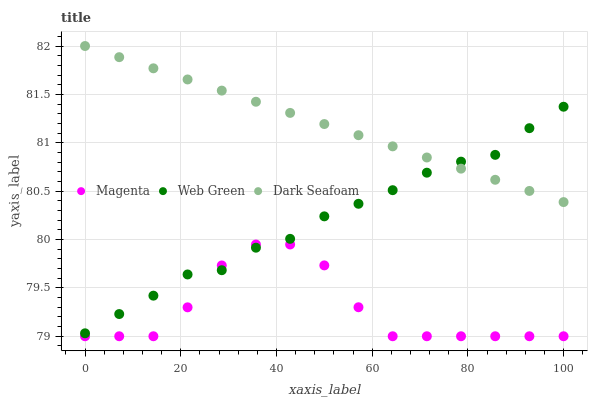Does Magenta have the minimum area under the curve?
Answer yes or no. Yes. Does Dark Seafoam have the maximum area under the curve?
Answer yes or no. Yes. Does Web Green have the minimum area under the curve?
Answer yes or no. No. Does Web Green have the maximum area under the curve?
Answer yes or no. No. Is Dark Seafoam the smoothest?
Answer yes or no. Yes. Is Magenta the roughest?
Answer yes or no. Yes. Is Web Green the smoothest?
Answer yes or no. No. Is Web Green the roughest?
Answer yes or no. No. Does Magenta have the lowest value?
Answer yes or no. Yes. Does Web Green have the lowest value?
Answer yes or no. No. Does Dark Seafoam have the highest value?
Answer yes or no. Yes. Does Web Green have the highest value?
Answer yes or no. No. Is Magenta less than Dark Seafoam?
Answer yes or no. Yes. Is Dark Seafoam greater than Magenta?
Answer yes or no. Yes. Does Dark Seafoam intersect Web Green?
Answer yes or no. Yes. Is Dark Seafoam less than Web Green?
Answer yes or no. No. Is Dark Seafoam greater than Web Green?
Answer yes or no. No. Does Magenta intersect Dark Seafoam?
Answer yes or no. No. 